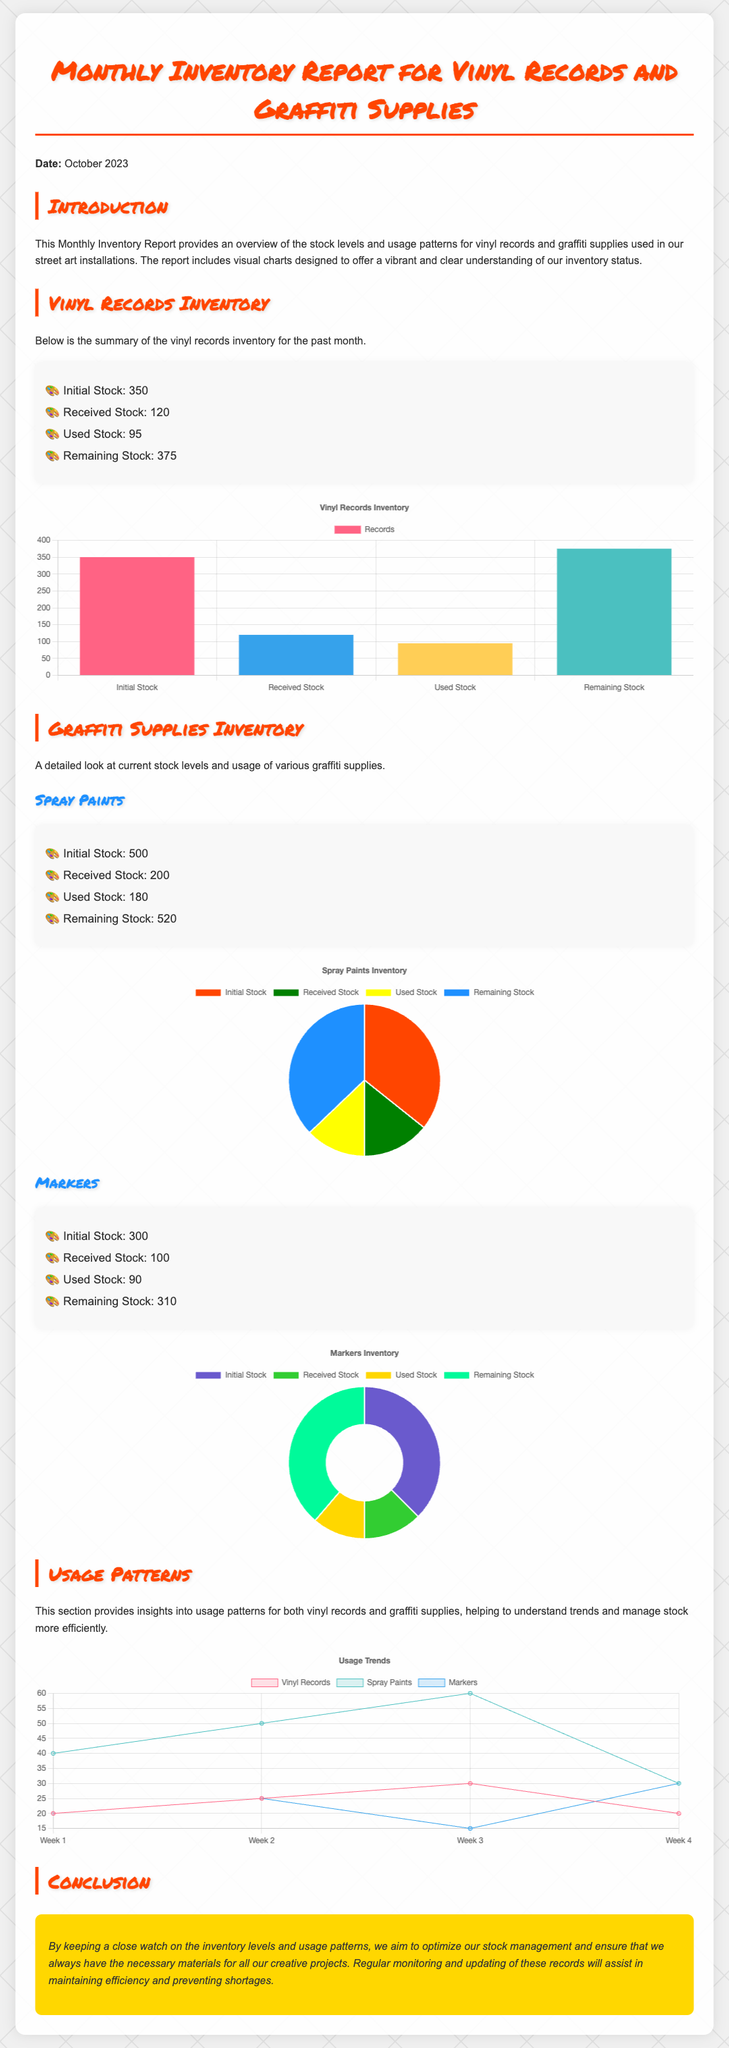What is the date of the report? The date of the report is mentioned in the introduction of the document.
Answer: October 2023 What is the initial stock of vinyl records? The initial stock for vinyl records is specified in the inventory summary.
Answer: 350 How many spray paints were used? The number of used spray paints is provided in the summary section for spray paints.
Answer: 180 What is the remaining stock of markers? The remaining stock of markers is stated in the inventory summary for markers.
Answer: 310 Which chart type is used for vinyl records inventory? The chart type is indicated in the code section that defines the visualization of vinyl records.
Answer: Bar How many spray paints were received? The received stock of spray paints is mentioned in the corresponding data summary.
Answer: 200 What trend does the usage chart show? The usage chart captures trends across different supplies, requiring interpretation of multiple data points.
Answer: Usage Trends What color represents the remaining stock of vinyl records? The colors for each stock category are detailed in the chart settings, indicating visual representation.
Answer: Teal What is the total number of initial stock items for graffiti supplies? This can be determined by adding the initial stock of spray paints and markers.
Answer: 800 